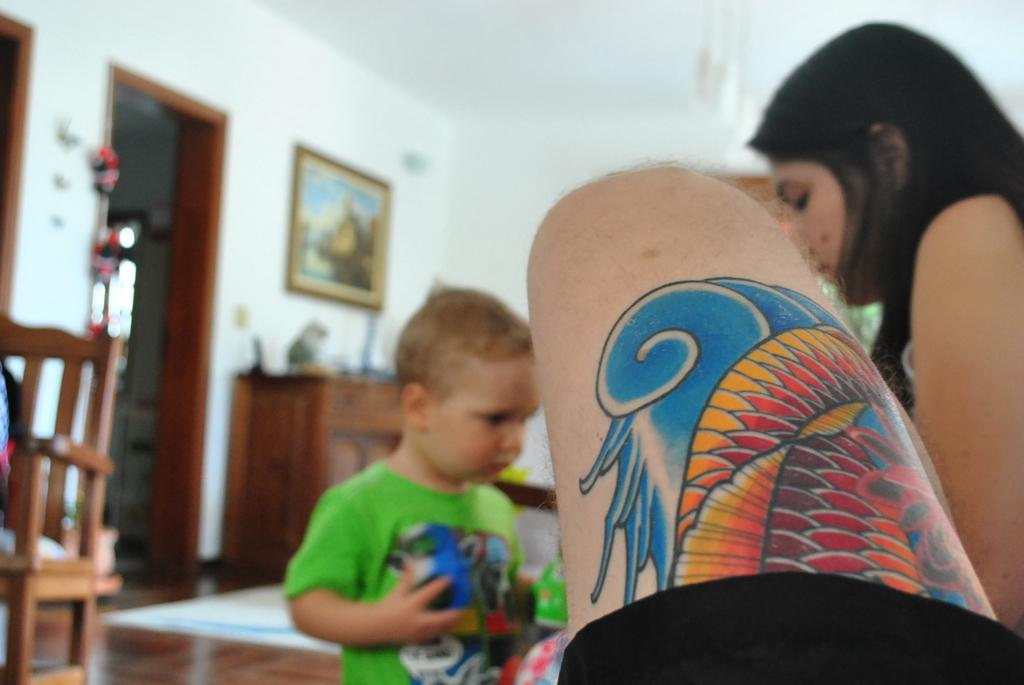What is covering the wall in the image? There is a frame over the wall in the image. What type of furniture is present in the image? There is a cupboard in the image. What type of flooring is present in the image? There is a floor carpet in the image. What type of flooring is present in the image? There is a floor visible in the image. What is the relationship between the boy and the woman in the image? There is a boy standing near a woman in the image. What type of body art is visible on a person's body in the image? There is a tattoo on a person's thigh in the image. What type of protest is happening in the image? There is no protest present in the image. 